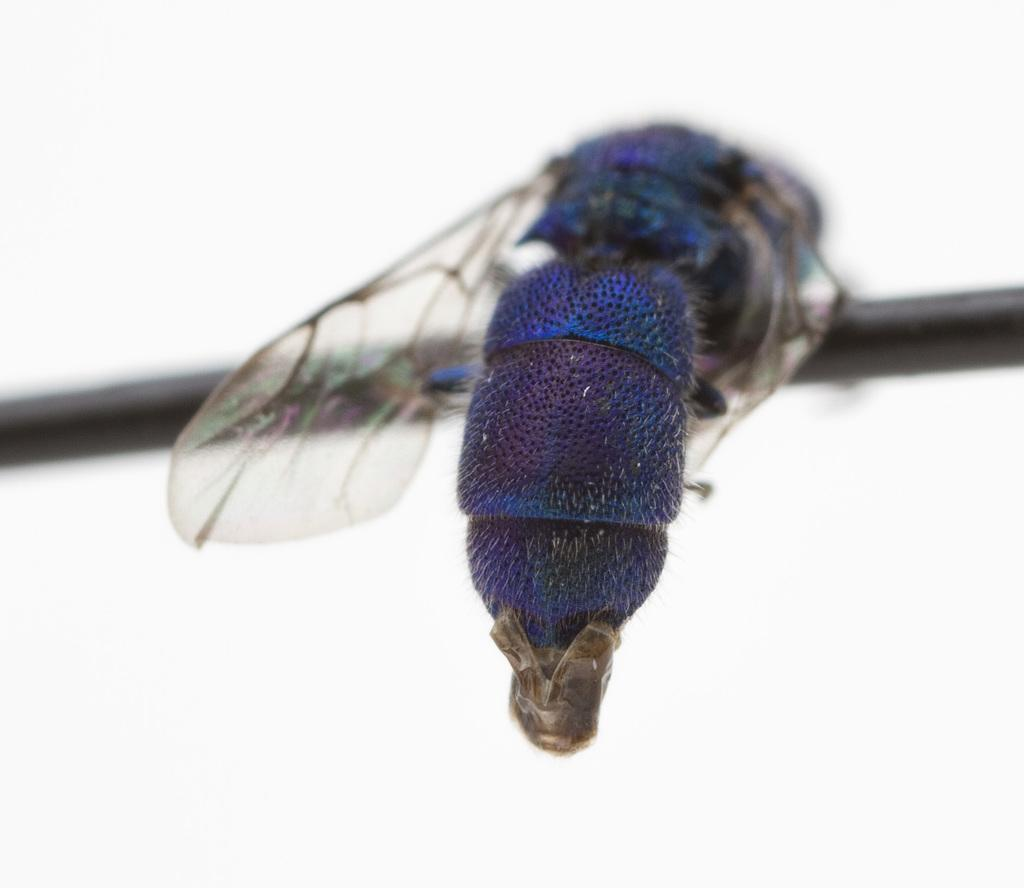What is the main subject of the image? The main subject of the image is a house fly. Where is the house fly located in the image? The house fly is on an object in the image. What color is the background of the image? The background of the image is white. What type of glue is the house fly using to stick to the object in the image? There is no indication in the image that the house fly is using glue to stick to the object. What kind of straw is the house fly holding in the image? There is no straw present in the image; it only features a house fly on an object. 